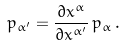Convert formula to latex. <formula><loc_0><loc_0><loc_500><loc_500>p _ { \alpha ^ { \prime } } = \frac { \partial x ^ { \alpha } } { \partial x ^ { \alpha ^ { \prime } } } \, p _ { \alpha } \, .</formula> 